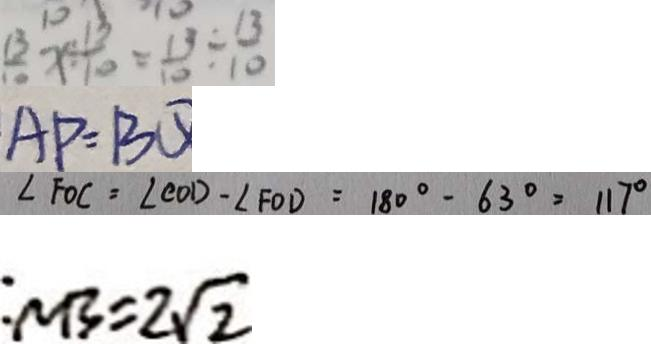<formula> <loc_0><loc_0><loc_500><loc_500>\frac { 1 3 } { ! 0 } x \div \frac { 1 3 } { 1 0 } = \frac { 1 3 } { 1 0 } \div \frac { 1 3 } { 1 0 } 
 A P = B Q 
 \angle F O C = \angle C O D - \angle F O D = 1 8 0 ^ { \circ } - 6 3 ^ { \circ } = 1 1 7 ^ { \circ } 
 : N B = 2 \sqrt { 2 }</formula> 